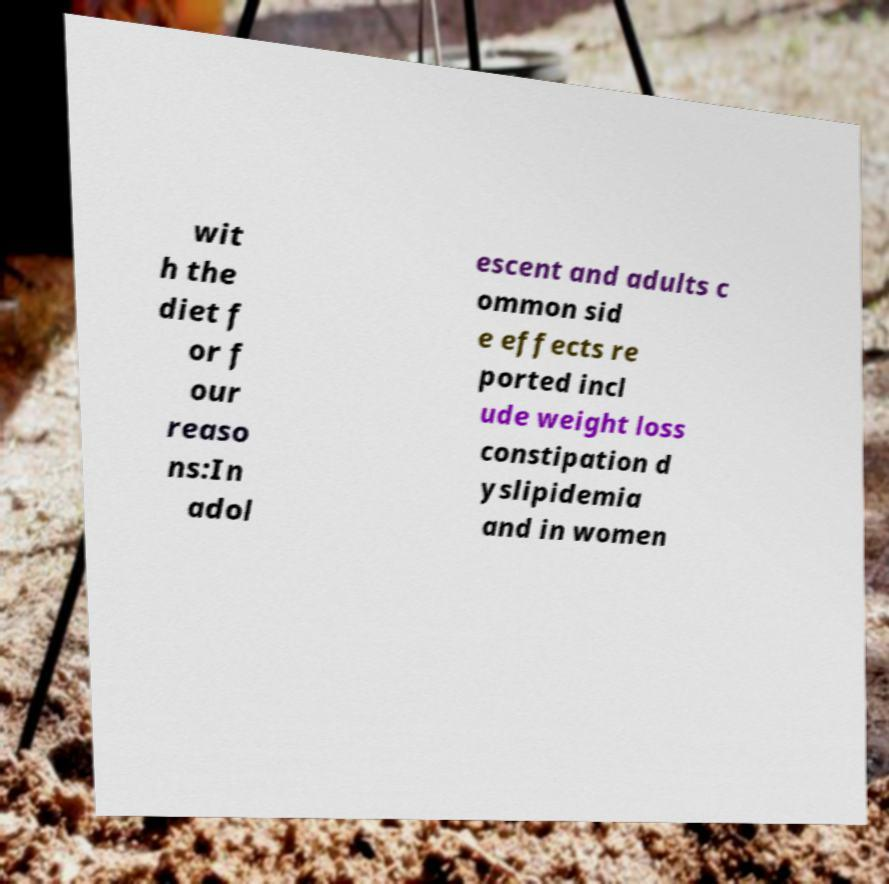For documentation purposes, I need the text within this image transcribed. Could you provide that? wit h the diet f or f our reaso ns:In adol escent and adults c ommon sid e effects re ported incl ude weight loss constipation d yslipidemia and in women 